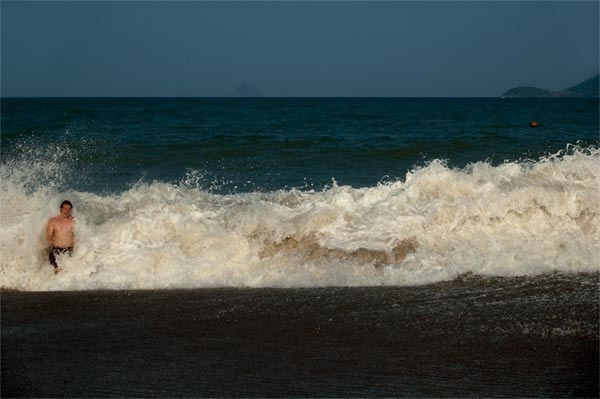Describe the objects in this image and their specific colors. I can see people in gray, tan, black, and brown tones in this image. 